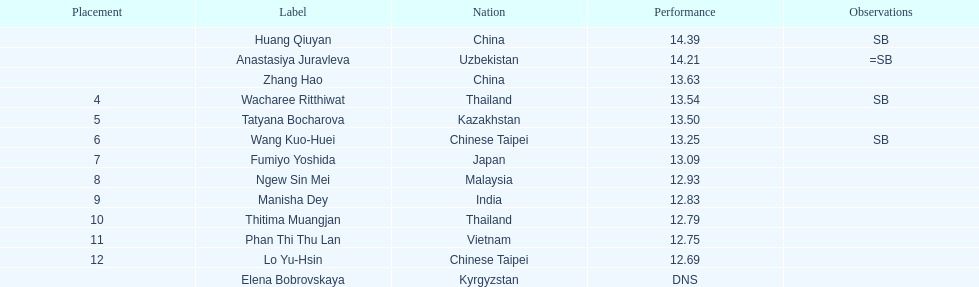How many points apart were the 1st place competitor and the 12th place competitor? 1.7. 